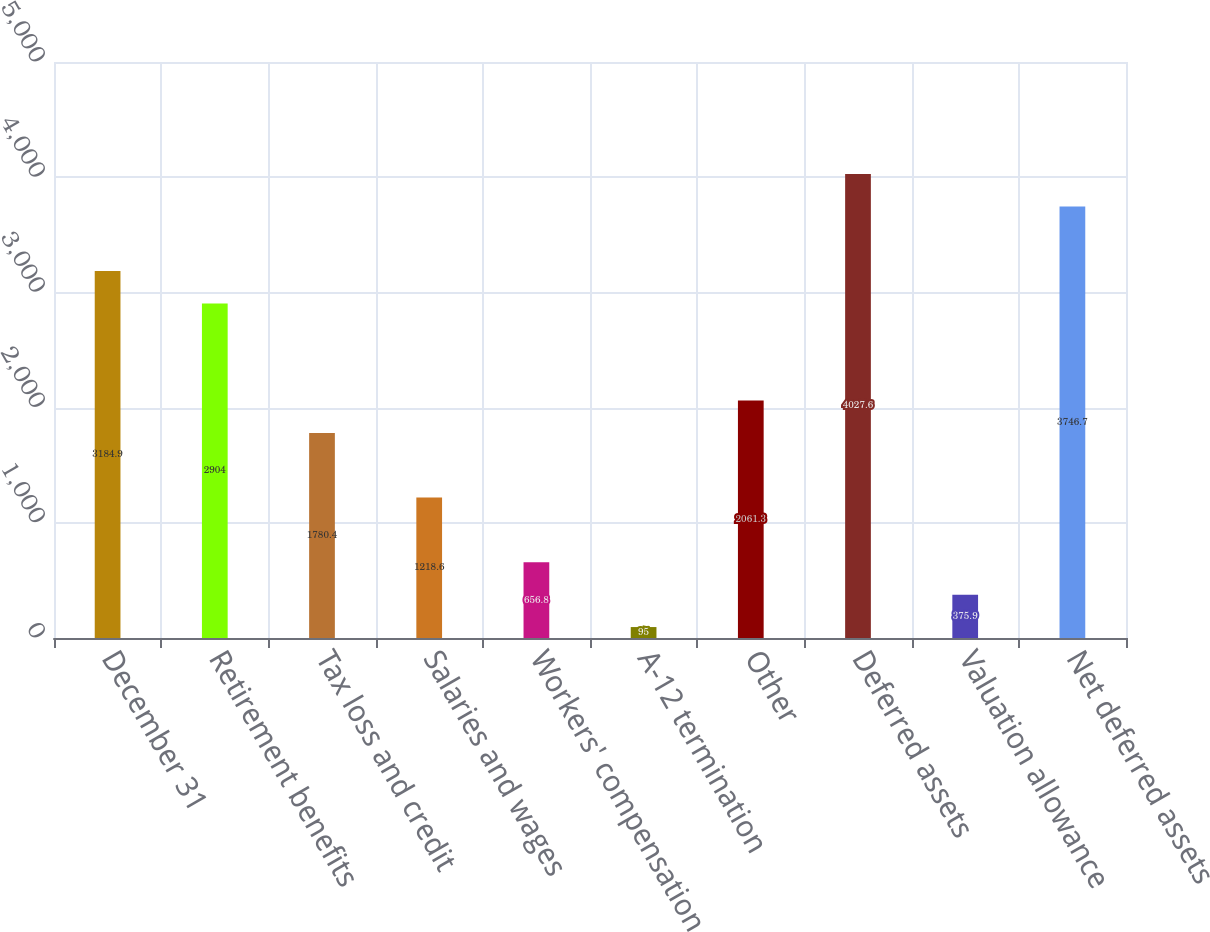<chart> <loc_0><loc_0><loc_500><loc_500><bar_chart><fcel>December 31<fcel>Retirement benefits<fcel>Tax loss and credit<fcel>Salaries and wages<fcel>Workers' compensation<fcel>A-12 termination<fcel>Other<fcel>Deferred assets<fcel>Valuation allowance<fcel>Net deferred assets<nl><fcel>3184.9<fcel>2904<fcel>1780.4<fcel>1218.6<fcel>656.8<fcel>95<fcel>2061.3<fcel>4027.6<fcel>375.9<fcel>3746.7<nl></chart> 